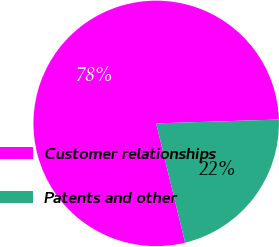<chart> <loc_0><loc_0><loc_500><loc_500><pie_chart><fcel>Customer relationships<fcel>Patents and other<nl><fcel>78.29%<fcel>21.71%<nl></chart> 